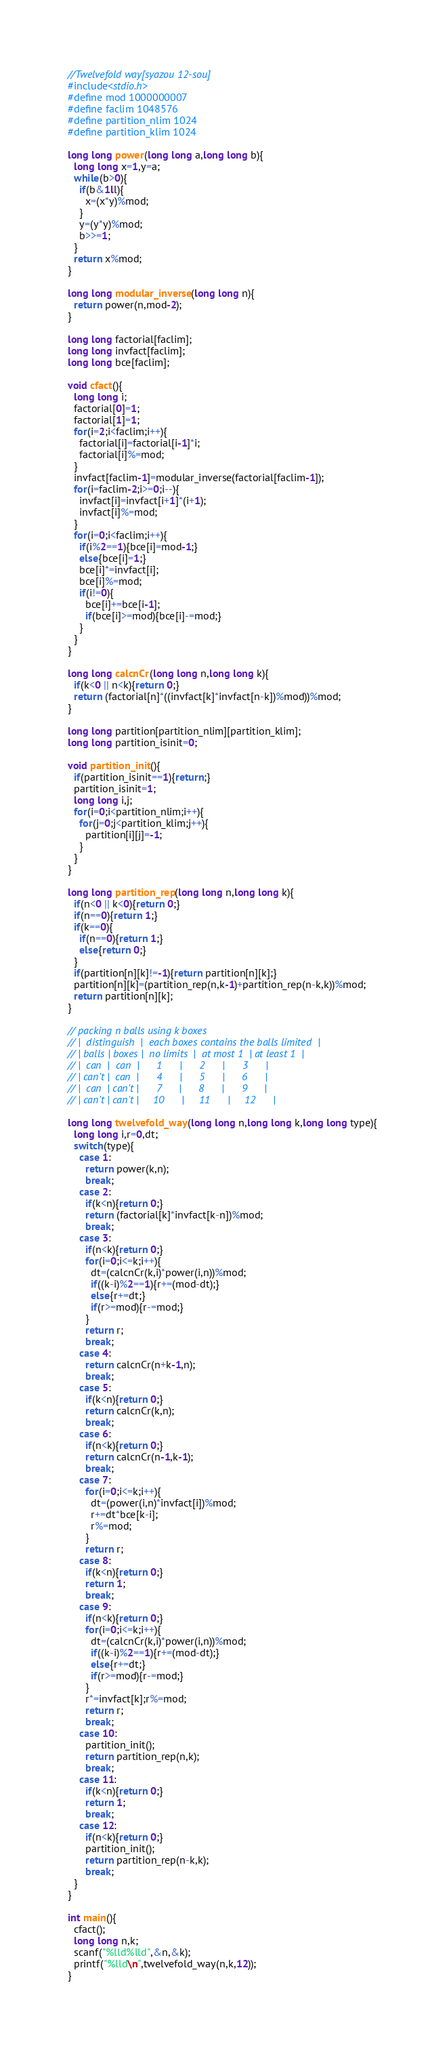<code> <loc_0><loc_0><loc_500><loc_500><_C_>//Twelvefold way[syazou 12-sou]
#include<stdio.h>
#define mod 1000000007
#define faclim 1048576
#define partition_nlim 1024
#define partition_klim 1024

long long power(long long a,long long b){
  long long x=1,y=a;
  while(b>0){
    if(b&1ll){
      x=(x*y)%mod;
    }
    y=(y*y)%mod;
    b>>=1;
  }
  return x%mod;
}

long long modular_inverse(long long n){
  return power(n,mod-2);
}

long long factorial[faclim];
long long invfact[faclim];
long long bce[faclim];

void cfact(){
  long long i;
  factorial[0]=1;
  factorial[1]=1;
  for(i=2;i<faclim;i++){
    factorial[i]=factorial[i-1]*i;
    factorial[i]%=mod;
  }
  invfact[faclim-1]=modular_inverse(factorial[faclim-1]);
  for(i=faclim-2;i>=0;i--){
    invfact[i]=invfact[i+1]*(i+1);
    invfact[i]%=mod;
  }
  for(i=0;i<faclim;i++){
    if(i%2==1){bce[i]=mod-1;}
    else{bce[i]=1;}
    bce[i]*=invfact[i];
    bce[i]%=mod;
    if(i!=0){
      bce[i]+=bce[i-1];
      if(bce[i]>=mod){bce[i]-=mod;}
    }
  }
}

long long calcnCr(long long n,long long k){
  if(k<0 || n<k){return 0;}
  return (factorial[n]*((invfact[k]*invfact[n-k])%mod))%mod;
}

long long partition[partition_nlim][partition_klim];
long long partition_isinit=0;

void partition_init(){
  if(partition_isinit==1){return;}
  partition_isinit=1;
  long long i,j;
  for(i=0;i<partition_nlim;i++){
    for(j=0;j<partition_klim;j++){
      partition[i][j]=-1;
    }
  }
}

long long partition_rep(long long n,long long k){
  if(n<0 || k<0){return 0;}
  if(n==0){return 1;}
  if(k==0){
    if(n==0){return 1;}
    else{return 0;}
  }
  if(partition[n][k]!=-1){return partition[n][k];}
  partition[n][k]=(partition_rep(n,k-1)+partition_rep(n-k,k))%mod;
  return partition[n][k];
}

// packing n balls using k boxes
// |  distinguish  |  each boxes contains the balls limited  |
// | balls | boxes |  no limits  |  at most 1  | at least 1  |
// |  can  |  can  |      1      |      2      |      3      |
// | can't |  can  |      4      |      5      |      6      |
// |  can  | can't |      7      |      8      |      9      |
// | can't | can't |     10      |     11      |     12      |

long long twelvefold_way(long long n,long long k,long long type){
  long long i,r=0,dt;
  switch(type){
    case 1:
      return power(k,n);
      break;
    case 2:
      if(k<n){return 0;}
      return (factorial[k]*invfact[k-n])%mod;
      break;
    case 3:
      if(n<k){return 0;}
      for(i=0;i<=k;i++){
        dt=(calcnCr(k,i)*power(i,n))%mod;
        if((k-i)%2==1){r+=(mod-dt);}
        else{r+=dt;}
        if(r>=mod){r-=mod;}
      }
      return r;
      break;
    case 4:
      return calcnCr(n+k-1,n);
      break;
    case 5:
      if(k<n){return 0;}
      return calcnCr(k,n);
      break;
    case 6:
      if(n<k){return 0;}
      return calcnCr(n-1,k-1);
      break;
    case 7:
      for(i=0;i<=k;i++){
        dt=(power(i,n)*invfact[i])%mod;
        r+=dt*bce[k-i];
        r%=mod;
      }
      return r;
    case 8:
      if(k<n){return 0;}
      return 1;
      break;
    case 9:
      if(n<k){return 0;}
      for(i=0;i<=k;i++){
        dt=(calcnCr(k,i)*power(i,n))%mod;
        if((k-i)%2==1){r+=(mod-dt);}
        else{r+=dt;}
        if(r>=mod){r-=mod;}
      }
      r*=invfact[k];r%=mod;
      return r;
      break;
    case 10:
      partition_init();
      return partition_rep(n,k);
      break;
    case 11:
      if(k<n){return 0;}
      return 1;
      break;
    case 12:
      if(n<k){return 0;}
      partition_init();
      return partition_rep(n-k,k);
      break;
  }
}

int main(){
  cfact();
  long long n,k;
  scanf("%lld%lld",&n,&k);
  printf("%lld\n",twelvefold_way(n,k,12));
}

</code> 